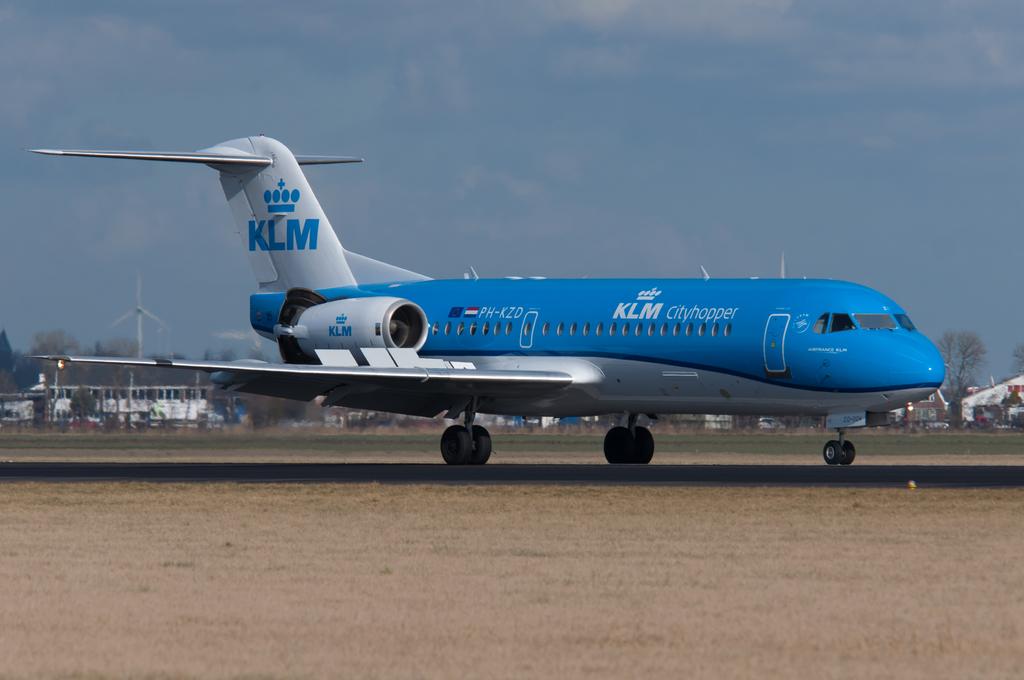Is klm the name of the airlines?
Provide a short and direct response. Yes. What is written in white on the plane body?
Provide a short and direct response. Klm cityhopper. 